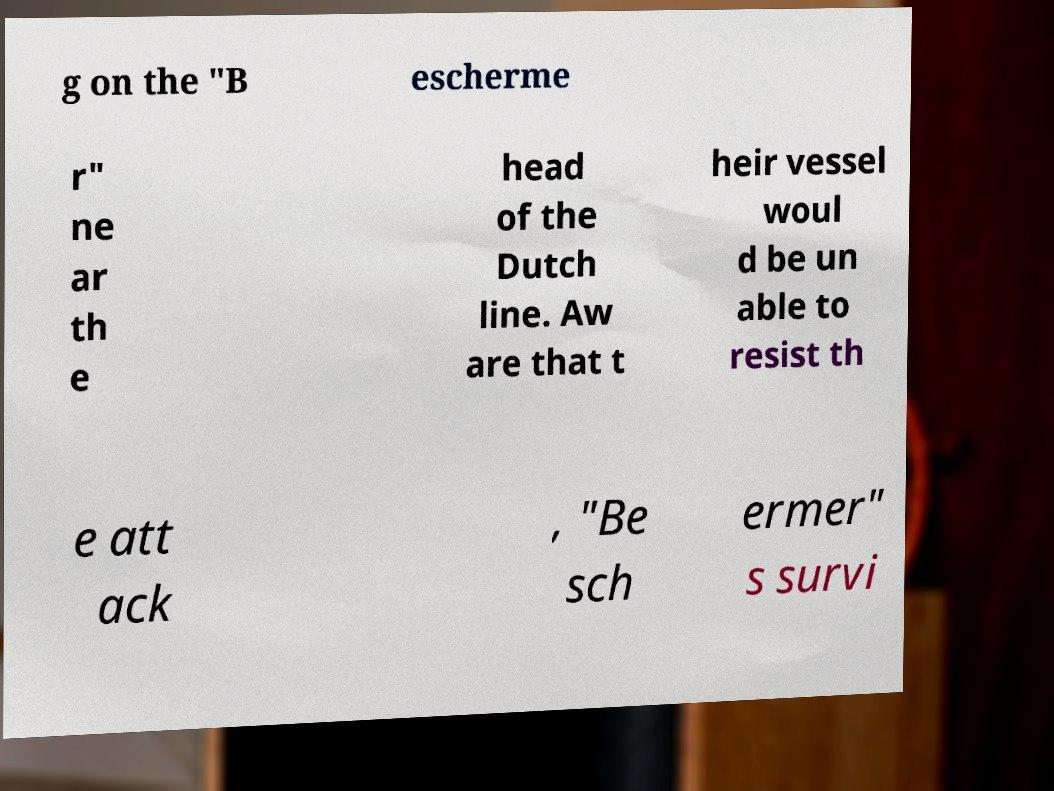Could you assist in decoding the text presented in this image and type it out clearly? g on the "B escherme r" ne ar th e head of the Dutch line. Aw are that t heir vessel woul d be un able to resist th e att ack , "Be sch ermer" s survi 